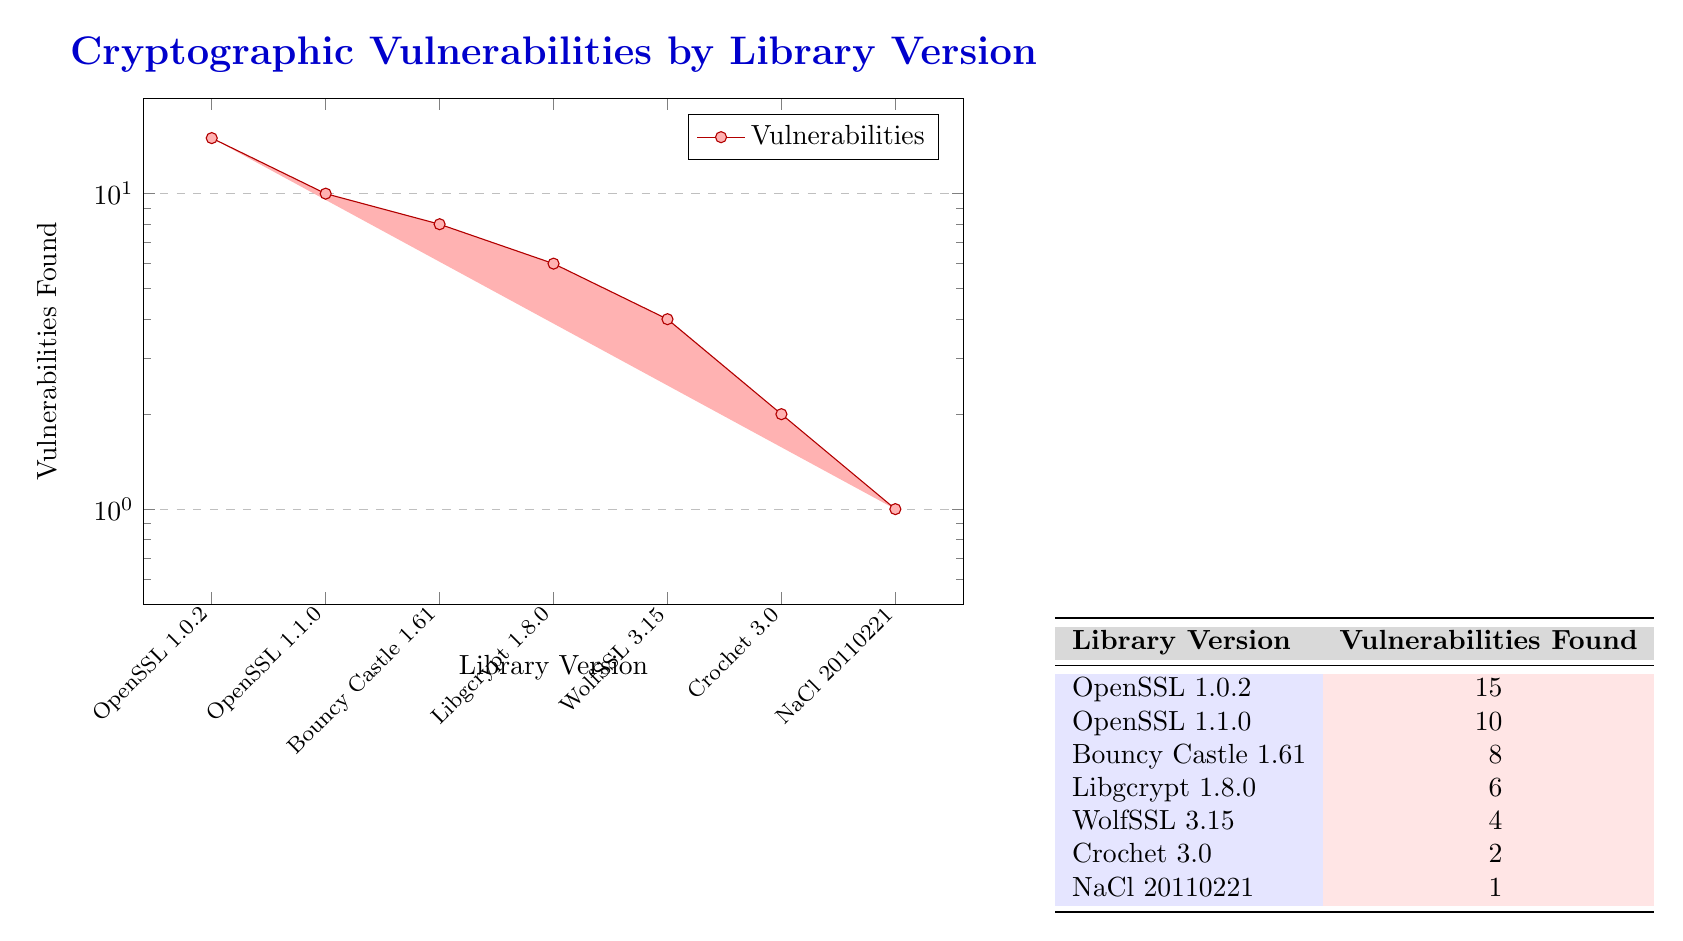What is the total number of vulnerabilities found across all library versions? To find the total number of vulnerabilities, we sum the vulnerabilities found in each library version: 15 + 10 + 8 + 6 + 4 + 2 + 1 = 46.
Answer: 46 Which library version has the highest number of vulnerabilities? By looking through the table, we see that "OpenSSL 1.0.2" has the highest count with 15 vulnerabilities.
Answer: OpenSSL 1.0.2 Is it true that "Libgcrypt 1.8.0" has more vulnerabilities than "WolfSSL 3.15"? Checking the table, "Libgcrypt 1.8.0" has 6 vulnerabilities, while "WolfSSL 3.15" has 4 vulnerabilities. Since 6 is greater than 4, the statement is true.
Answer: Yes What is the average number of vulnerabilities found per library version? There are 7 library versions in total. The total number of vulnerabilities is 46. The average is calculated by dividing the total vulnerabilities by the number of versions: 46 / 7 = approximately 6.57.
Answer: 6.57 Which library versions have fewer than 5 vulnerabilities? From the table, both "WolfSSL 3.15" (4 vulnerabilities) and "Crochet 3.0" (2 vulnerabilities) have fewer than 5 vulnerabilities. We also have "NaCl 20110221" with 1 vulnerability.
Answer: WolfSSL 3.15, Crochet 3.0, NaCl 20110221 What is the difference in the number of vulnerabilities between "OpenSSL 1.0.2" and "Bouncy Castle 1.61"? "OpenSSL 1.0.2" has 15 vulnerabilities, while "Bouncy Castle 1.61" has 8. The difference is 15 - 8 = 7 vulnerabilities.
Answer: 7 Has "NaCl 20110221" been identified with more vulnerabilities than "Crochet 3.0"? "NaCl 20110221" has 1 vulnerability, while "Crochet 3.0" has 2 vulnerabilities. Therefore, "NaCl" does not have more vulnerabilities than "Crochet".
Answer: No Which library versions have at least 6 vulnerabilities? Looking at the table, "OpenSSL 1.0.2" (15), "OpenSSL 1.1.0" (10), "Bouncy Castle 1.61" (8), and "Libgcrypt 1.8.0" (6) all have at least 6 vulnerabilities.
Answer: OpenSSL 1.0.2, OpenSSL 1.1.0, Bouncy Castle 1.61, Libgcrypt 1.8.0 